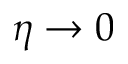<formula> <loc_0><loc_0><loc_500><loc_500>\eta \to 0</formula> 